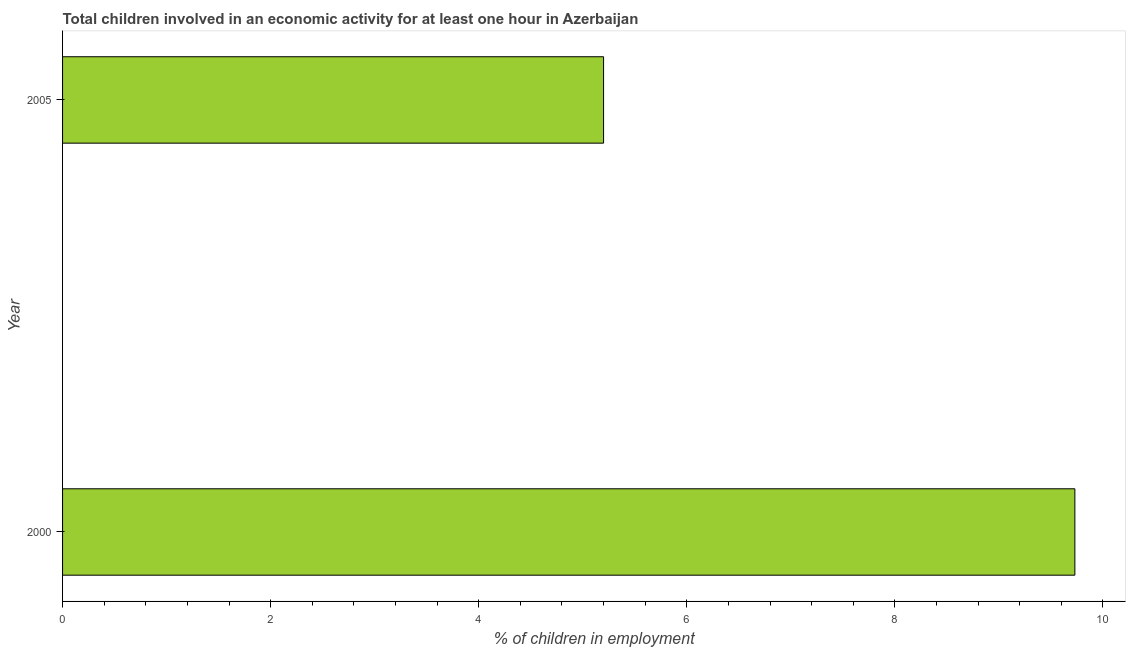Does the graph contain any zero values?
Ensure brevity in your answer.  No. Does the graph contain grids?
Your answer should be compact. No. What is the title of the graph?
Give a very brief answer. Total children involved in an economic activity for at least one hour in Azerbaijan. What is the label or title of the X-axis?
Give a very brief answer. % of children in employment. What is the label or title of the Y-axis?
Offer a very short reply. Year. What is the percentage of children in employment in 2000?
Provide a succinct answer. 9.73. Across all years, what is the maximum percentage of children in employment?
Offer a very short reply. 9.73. Across all years, what is the minimum percentage of children in employment?
Provide a succinct answer. 5.2. What is the sum of the percentage of children in employment?
Give a very brief answer. 14.93. What is the difference between the percentage of children in employment in 2000 and 2005?
Make the answer very short. 4.53. What is the average percentage of children in employment per year?
Make the answer very short. 7.46. What is the median percentage of children in employment?
Offer a terse response. 7.46. In how many years, is the percentage of children in employment greater than 9.6 %?
Offer a very short reply. 1. Do a majority of the years between 2000 and 2005 (inclusive) have percentage of children in employment greater than 2 %?
Keep it short and to the point. Yes. What is the ratio of the percentage of children in employment in 2000 to that in 2005?
Offer a terse response. 1.87. Is the percentage of children in employment in 2000 less than that in 2005?
Your response must be concise. No. How many years are there in the graph?
Your answer should be compact. 2. What is the difference between two consecutive major ticks on the X-axis?
Provide a short and direct response. 2. What is the % of children in employment of 2000?
Your answer should be very brief. 9.73. What is the % of children in employment of 2005?
Give a very brief answer. 5.2. What is the difference between the % of children in employment in 2000 and 2005?
Your answer should be compact. 4.53. What is the ratio of the % of children in employment in 2000 to that in 2005?
Make the answer very short. 1.87. 